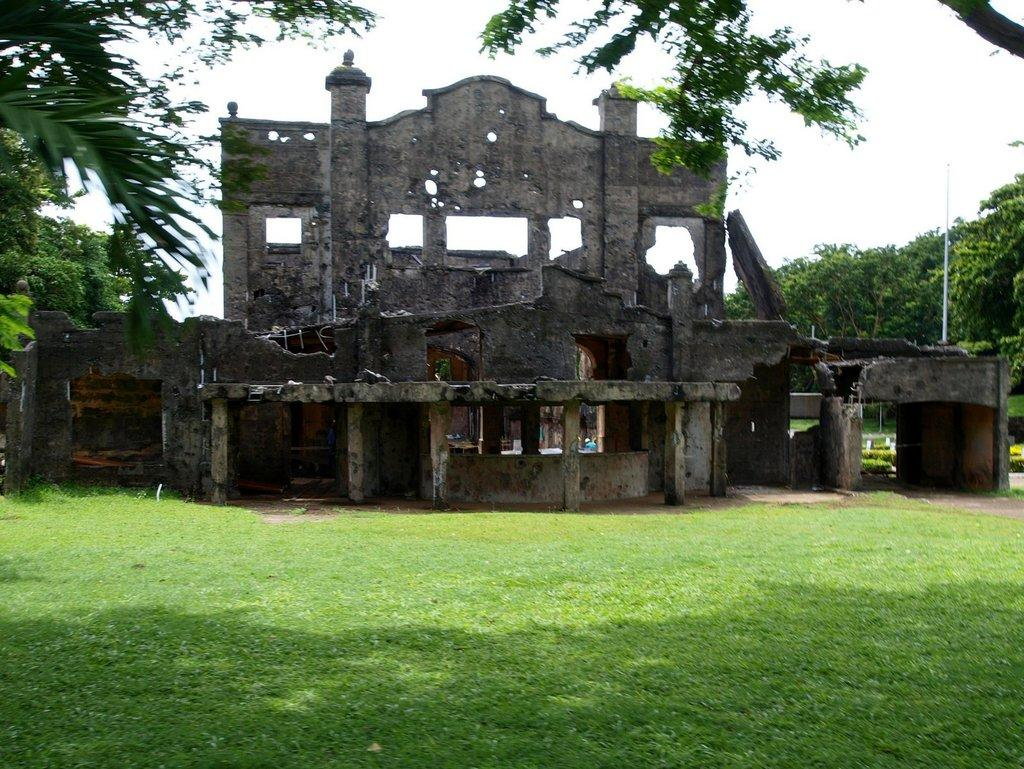What type of building is shown in the image? There is an old broken building in the image. What feature can be seen on the building? The building has windows. What type of vegetation is visible in the image? There is grass and trees visible in the image. What object can be seen in the image besides the building? There is a pole in the image. What is the condition of the sky in the image? The sky is visible in the image and appears cloudy. What type of nut is being used to hold the building together? There is no nut present in the image. The building is old and broken, and no such object is holding it together. 